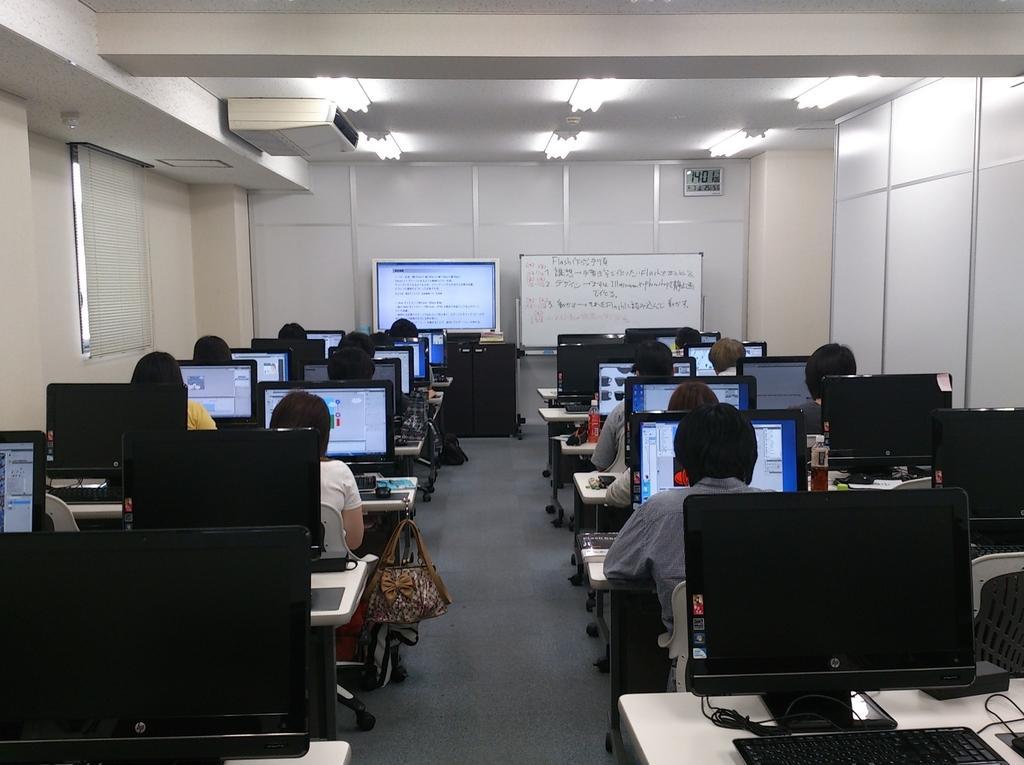Describe this image in one or two sentences. This is an inside view of a room. In this picture we can see people sitting on the chairs. On the tables we can see monitors, keyboards and objects. In the background we can see a screen and boards. At the top we can see the ceiling and lights. On the left side of the picture we can see a window blind. We can see the floor and objects.   